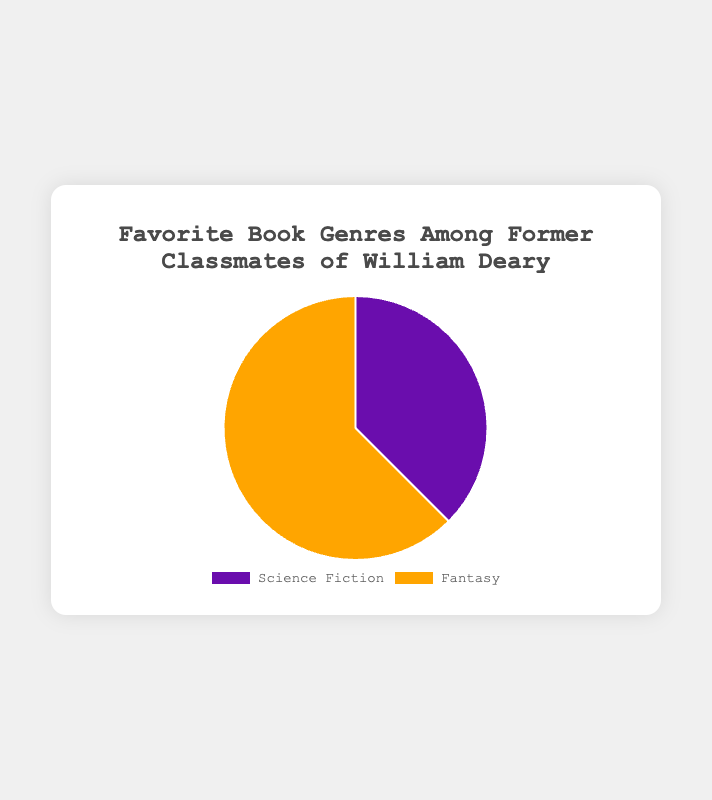Which genre is the most popular among former classmates of William Deary? The pie chart shows two genres, Science Fiction and Fantasy. Fantasy has a larger slice of the pie chart, indicating it is more popular.
Answer: Fantasy How many more classmates prefer Fantasy over Science Fiction? The numbers in the chart show that 25 classmates prefer Fantasy and 15 prefer Science Fiction. The difference is 25 - 15.
Answer: 10 What is the total number of classmates surveyed? The chart indicates that 15 classmates like Science Fiction and 25 classmates like Fantasy. Adding these together gives the total number surveyed.
Answer: 40 What percentage of classmates prefer Science Fiction? 15 out of 40 classmates prefer Science Fiction. To find the percentage, use the formula (15/40) * 100.
Answer: 37.5% What is the ratio of classmates who prefer Fantasy to those who prefer Science Fiction? The chart indicates 25 classmates prefer Fantasy and 15 prefer Science Fiction. The ratio is 25:15, which simplifies to 5:3.
Answer: 5:3 Which genre has a larger slice of the pie chart? Visually inspecting the chart, the slice for Fantasy is larger than the slice for Science Fiction.
Answer: Fantasy If 10 more classmates were surveyed and they all preferred Science Fiction, what would be the new count for Science Fiction? The current count is 15. Adding 10 more who prefer Science Fiction would make it 15 + 10.
Answer: 25 How does the color of the slices help to identify the genres? The pie chart uses different colors to differentiate genres. Science Fiction is colored purple, while Fantasy is orange.
Answer: Science Fiction is purple, Fantasy is orange If the number of classmates who prefer Fantasy were to double, what would be the new total count for Fantasy? Currently, 25 classmates prefer Fantasy. Doubling this amount would be 25 * 2.
Answer: 50 What fraction of the classmates prefer Science Fiction? 15 out of 40 classmates prefer Science Fiction. This fraction can be represented as 15/40 and simplified to 3/8.
Answer: 3/8 